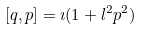Convert formula to latex. <formula><loc_0><loc_0><loc_500><loc_500>[ q , p ] = \imath ( 1 + l ^ { 2 } p ^ { 2 } )</formula> 